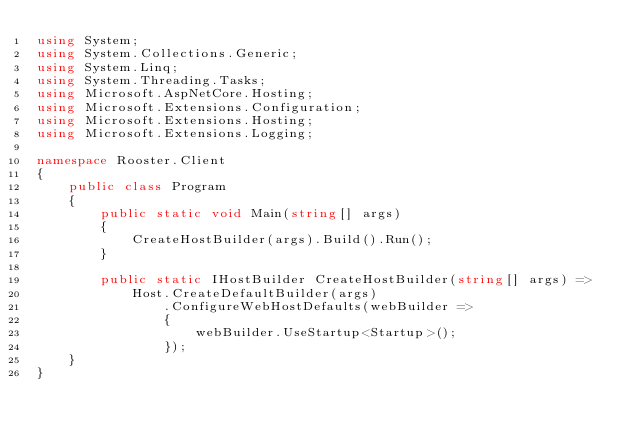<code> <loc_0><loc_0><loc_500><loc_500><_C#_>using System;
using System.Collections.Generic;
using System.Linq;
using System.Threading.Tasks;
using Microsoft.AspNetCore.Hosting;
using Microsoft.Extensions.Configuration;
using Microsoft.Extensions.Hosting;
using Microsoft.Extensions.Logging;

namespace Rooster.Client
{
    public class Program
    {
        public static void Main(string[] args)
        {
            CreateHostBuilder(args).Build().Run();
        }

        public static IHostBuilder CreateHostBuilder(string[] args) =>
            Host.CreateDefaultBuilder(args)
                .ConfigureWebHostDefaults(webBuilder =>
                {
                    webBuilder.UseStartup<Startup>();
                });
    }
}
</code> 